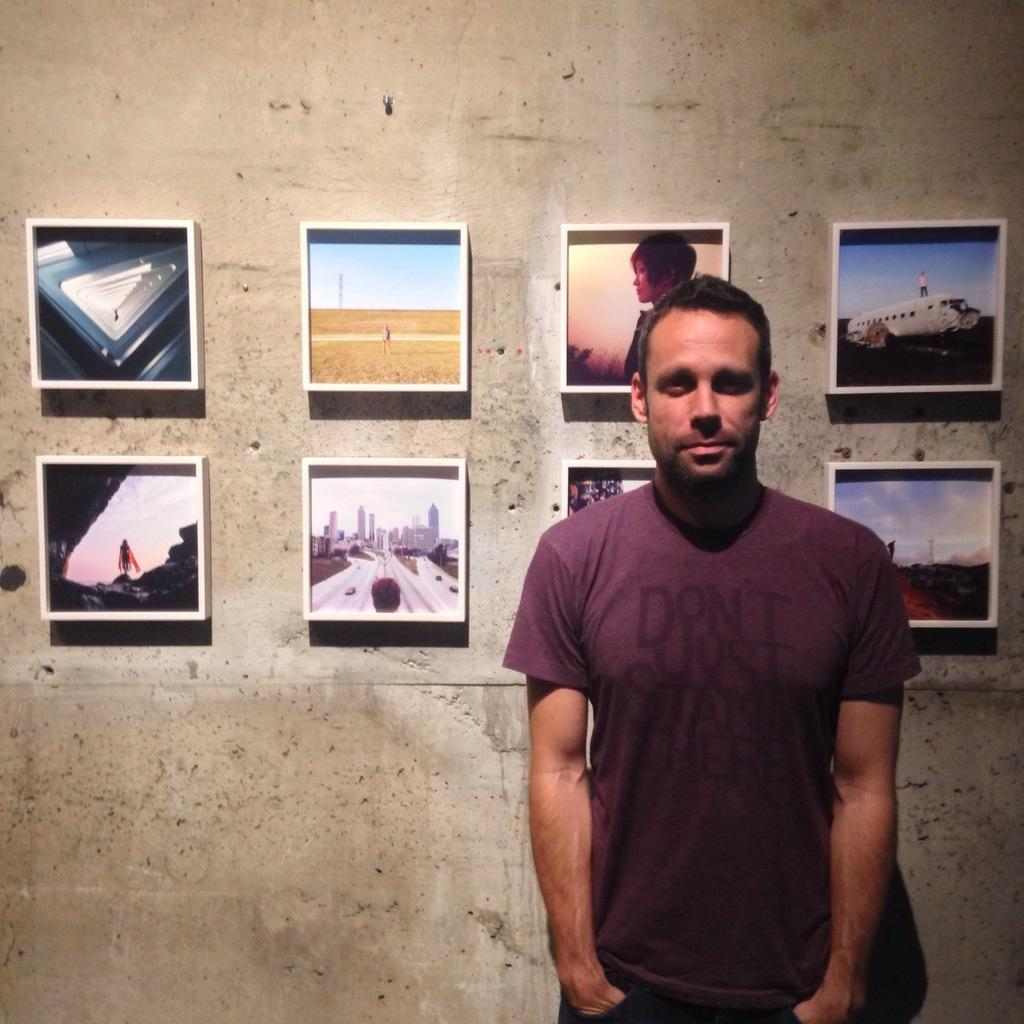What is the main subject in the foreground of the image? There is a man standing near a wall in the foreground of the image. What can be seen in the background of the image? There are frames attached to the wall in the background of the image. What type of knowledge can be gained from the hydrant in the image? There is no hydrant present in the image, so no knowledge can be gained from it. 